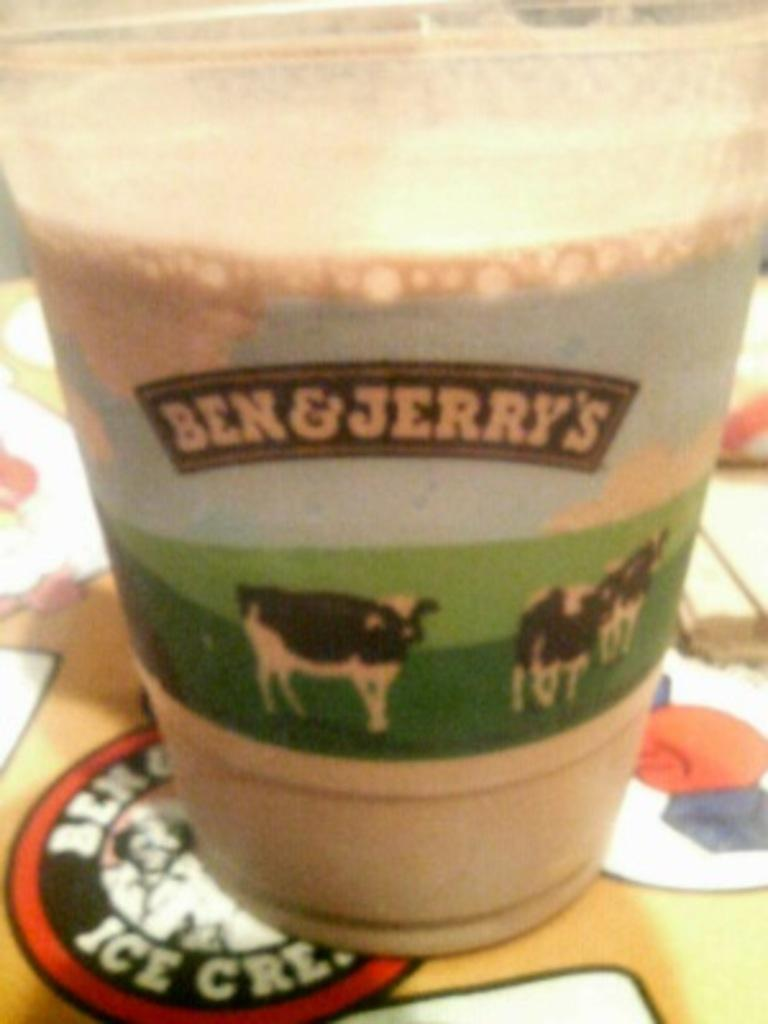What is present on the table in the image? There is a glass in the image. Where is the glass located on the table? The glass is placed on a table. What is inside the glass? The glass is filled with liquid. What is depicted on the glass? There are pictures of cows on the glass. Are there any words or phrases on the glass? Yes, there is text on the glass. How does the glass contribute to the destruction of the lock in the image? There is no lock present in the image, and the glass does not cause any destruction. 